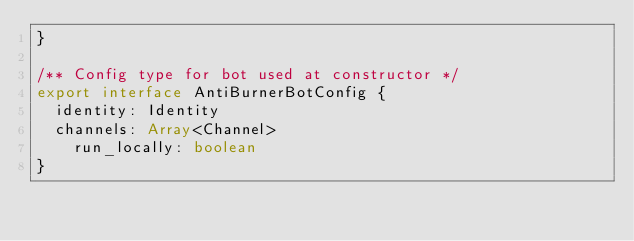Convert code to text. <code><loc_0><loc_0><loc_500><loc_500><_TypeScript_>}

/** Config type for bot used at constructor */
export interface AntiBurnerBotConfig {
	identity: Identity
	channels: Array<Channel>
    run_locally: boolean
}</code> 